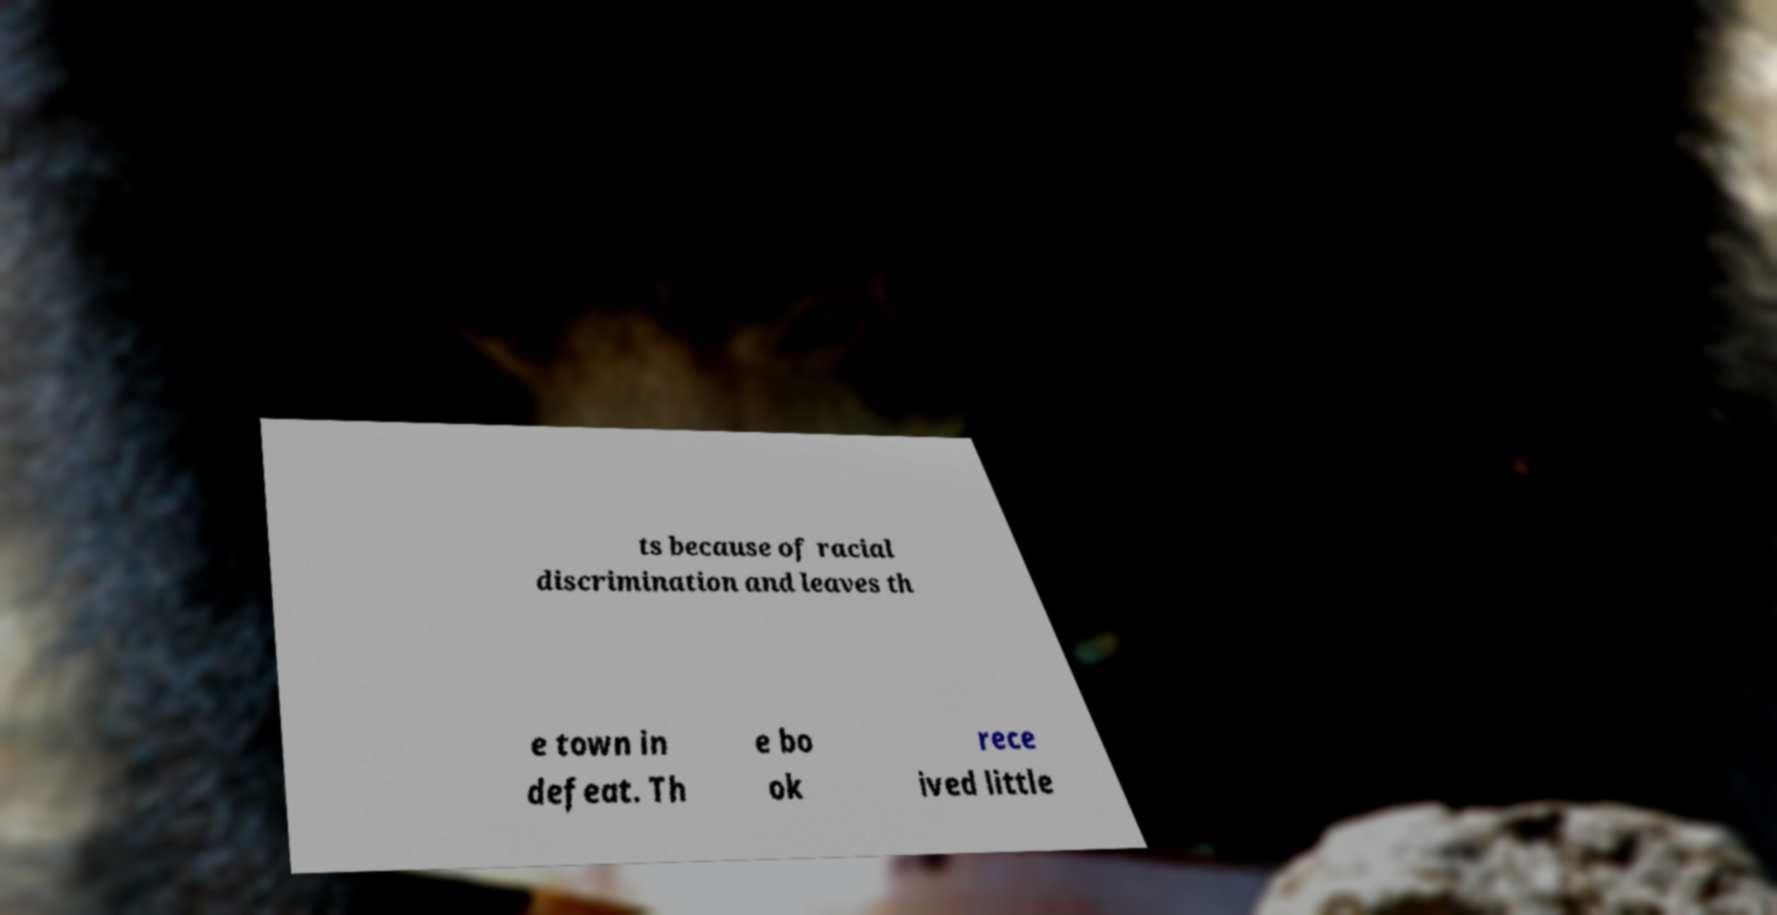Could you extract and type out the text from this image? ts because of racial discrimination and leaves th e town in defeat. Th e bo ok rece ived little 